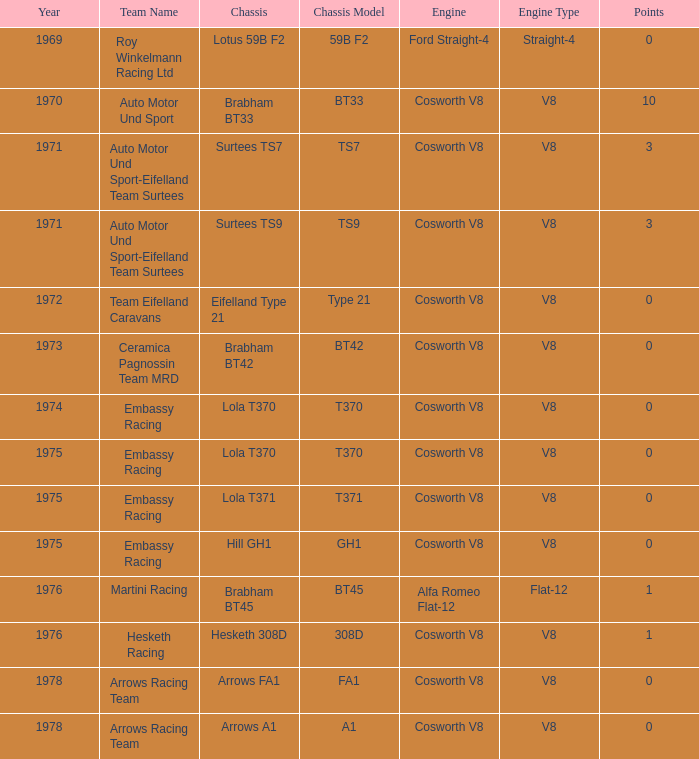What was the total amount of points in 1978 with a Chassis of arrows fa1? 0.0. 